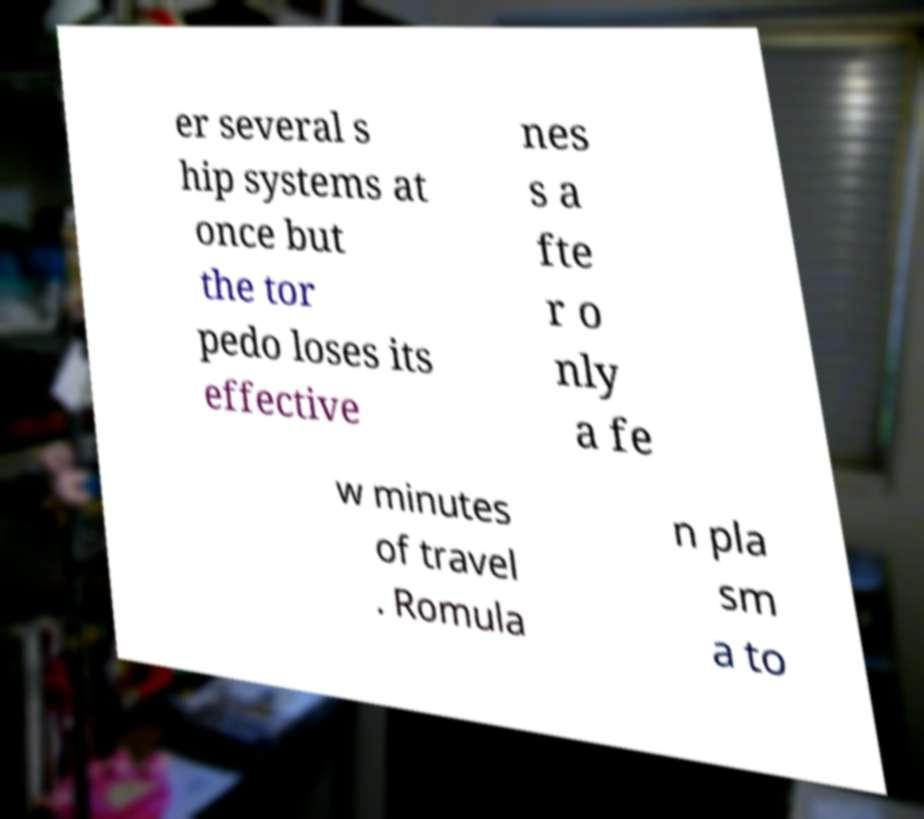Could you extract and type out the text from this image? er several s hip systems at once but the tor pedo loses its effective nes s a fte r o nly a fe w minutes of travel . Romula n pla sm a to 